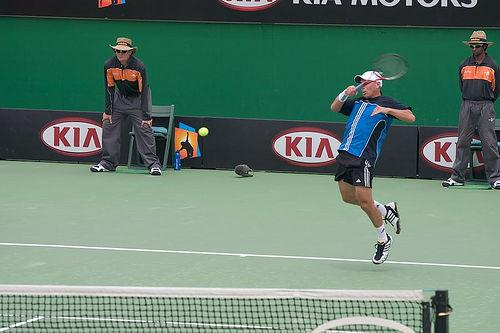What did the man in the blue shirt just do?

Choices:
A) served
B) quit
C) missed ball
D) returned ball returned ball 